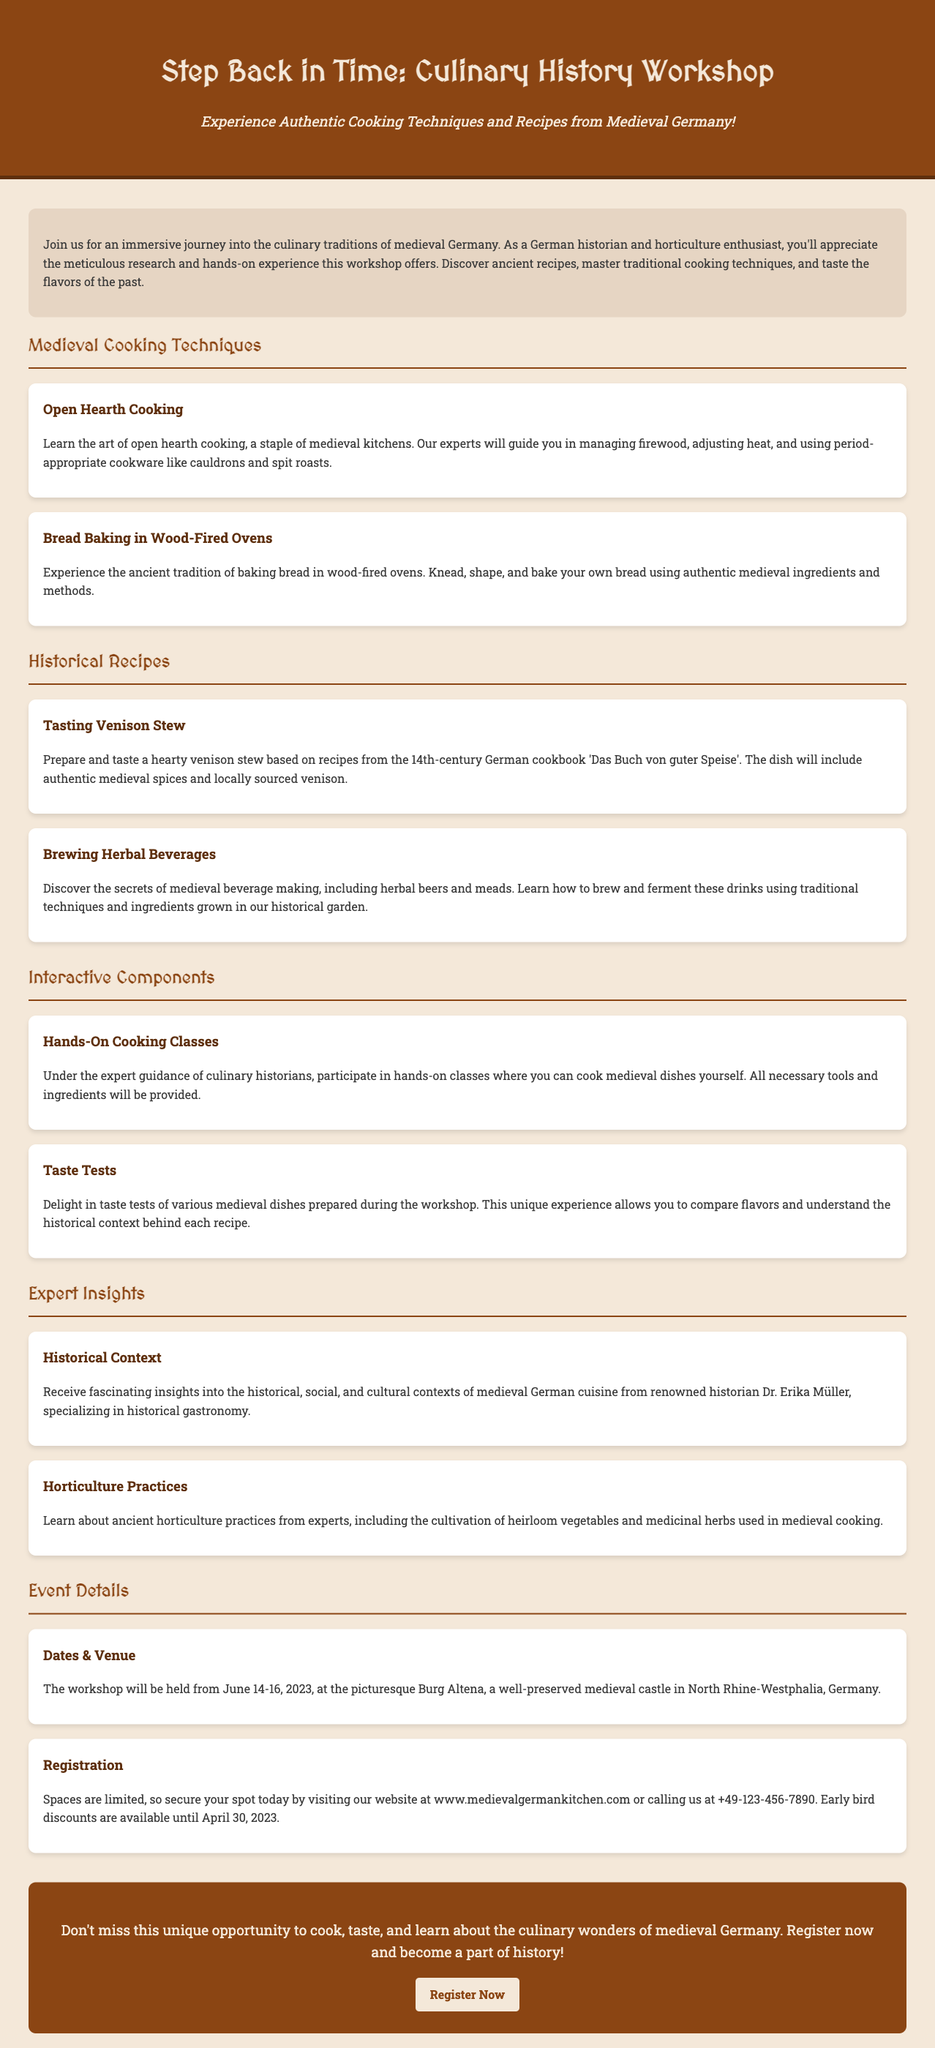What is the workshop's title? The title of the workshop is prominently displayed at the top of the document.
Answer: Culinary History Workshop When will the workshop take place? The dates for the workshop are provided in the "Event Details" section.
Answer: June 14-16, 2023 Where is the venue for the workshop? The venue is mentioned along with its description in the "Event Details" section.
Answer: Burg Altena Who will provide historical insights during the workshop? The document mentions a specific historian in the "Expert Insights" section.
Answer: Dr. Erika Müller What type of cooking technique will be taught related to bread? The document specifies a traditional cooking method under the cooking techniques section.
Answer: Wood-Fired Ovens What kind of stew will participants prepare? The specific dish mentioned in the historical recipes section includes details about its source.
Answer: Venison Stew What is one of the interactive components of the workshop? The document lists various interactive activities, one of which is emphasized in its respective section.
Answer: Hands-On Cooking Classes What contact method is provided for registration? The registration information specifies a contact method for inquiries.
Answer: Calling at +49-123-456-7890 